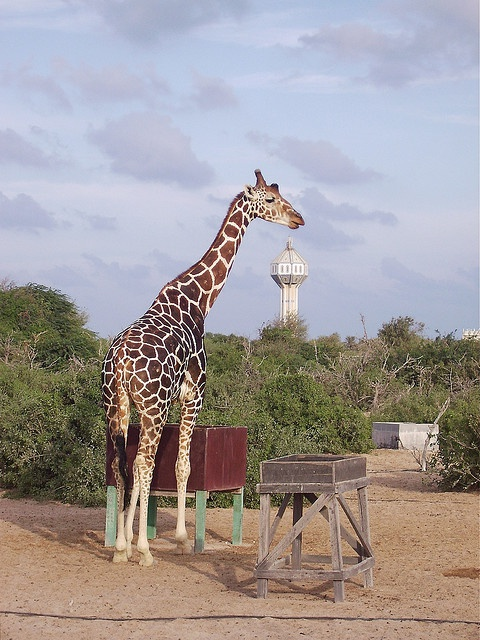Describe the objects in this image and their specific colors. I can see a giraffe in lavender, maroon, black, ivory, and brown tones in this image. 